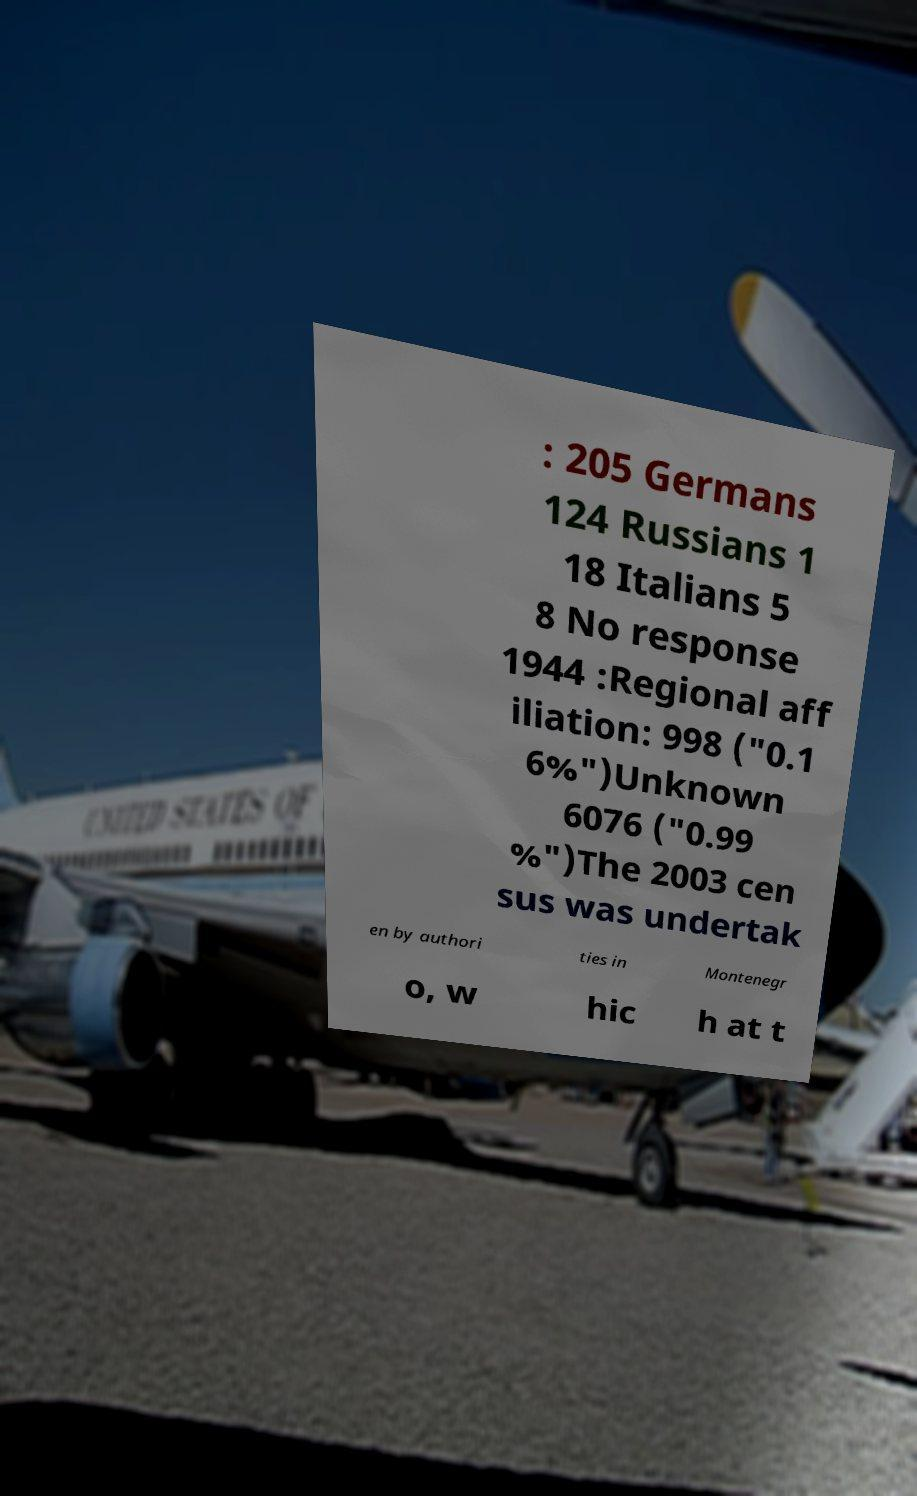What messages or text are displayed in this image? I need them in a readable, typed format. : 205 Germans 124 Russians 1 18 Italians 5 8 No response 1944 :Regional aff iliation: 998 ("0.1 6%")Unknown 6076 ("0.99 %")The 2003 cen sus was undertak en by authori ties in Montenegr o, w hic h at t 